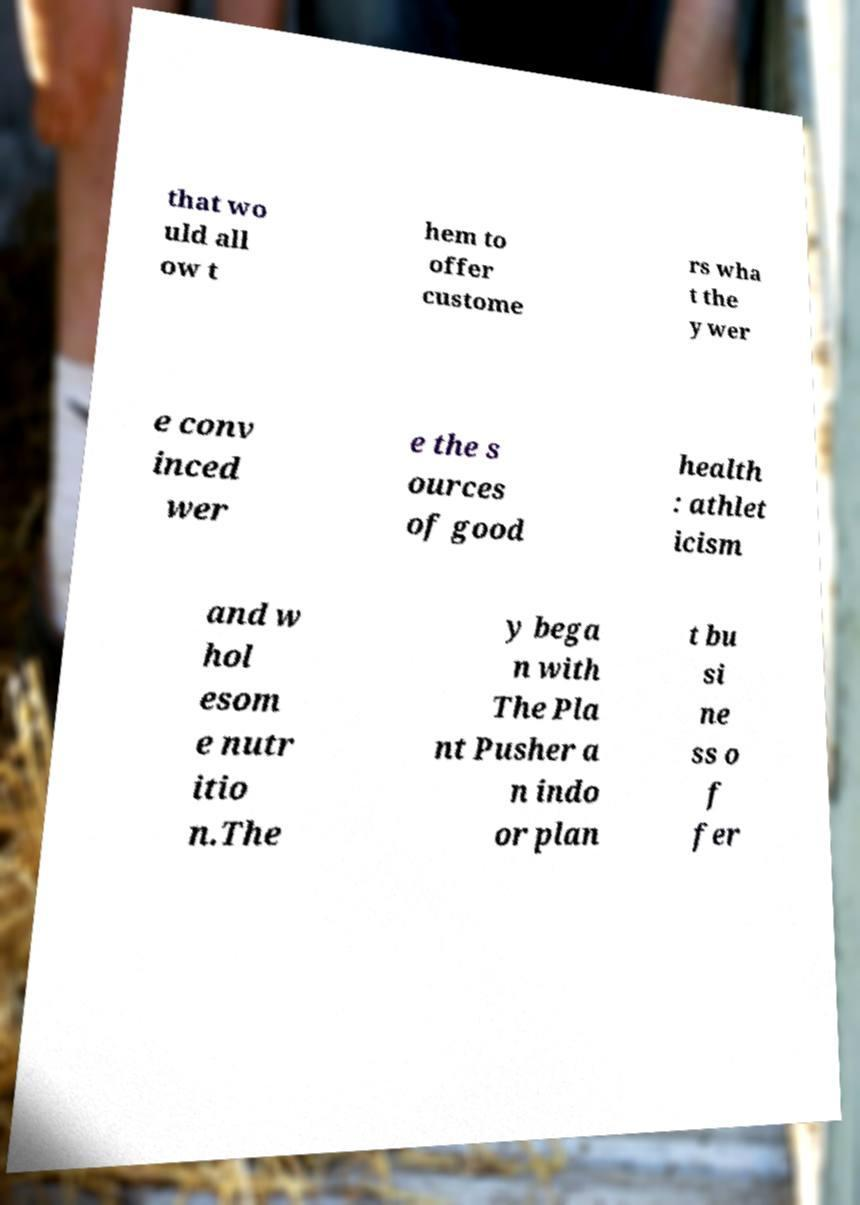What messages or text are displayed in this image? I need them in a readable, typed format. that wo uld all ow t hem to offer custome rs wha t the y wer e conv inced wer e the s ources of good health : athlet icism and w hol esom e nutr itio n.The y bega n with The Pla nt Pusher a n indo or plan t bu si ne ss o f fer 